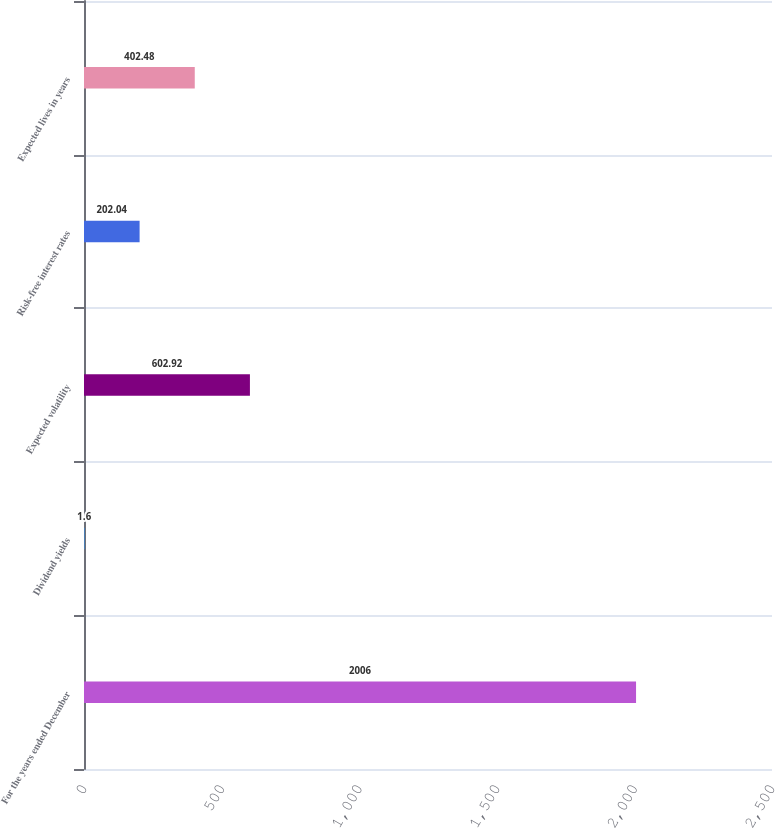Convert chart. <chart><loc_0><loc_0><loc_500><loc_500><bar_chart><fcel>For the years ended December<fcel>Dividend yields<fcel>Expected volatility<fcel>Risk-free interest rates<fcel>Expected lives in years<nl><fcel>2006<fcel>1.6<fcel>602.92<fcel>202.04<fcel>402.48<nl></chart> 